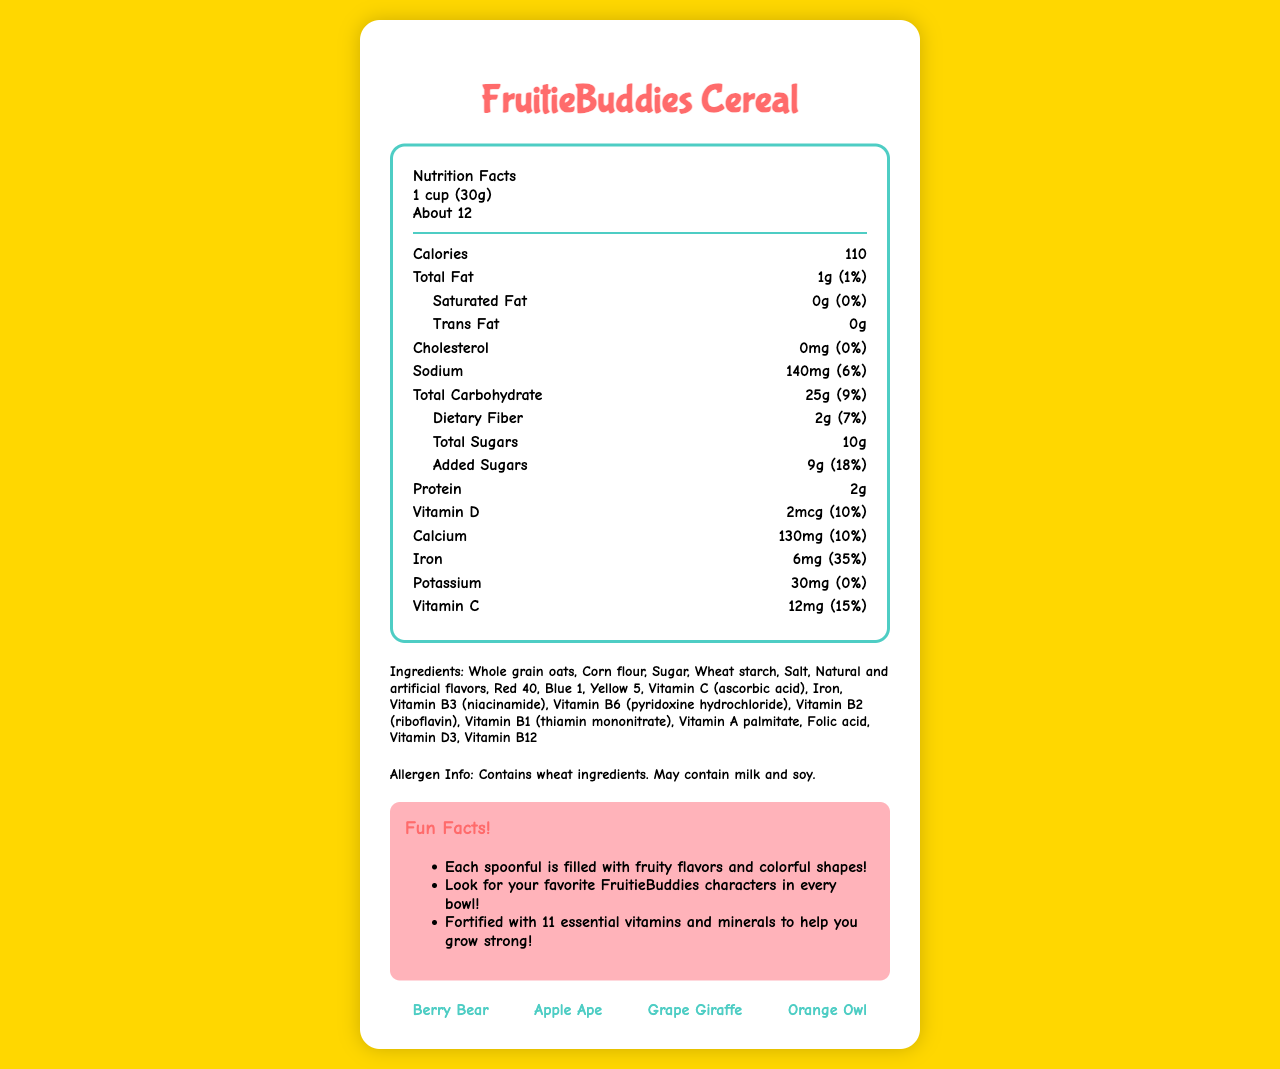How many calories are in a serving of FruitieBuddies Cereal? The document states that each serving of FruitieBuddies Cereal contains 110 calories.
Answer: 110 What is the serving size for FruitieBuddies Cereal? The serving size is explicitly mentioned as 1 cup (30g) in the document.
Answer: 1 cup (30g) How much iron does one serving of FruitieBuddies Cereal provide? The document specifies that each serving includes 6mg of iron, which is 35% of the daily value.
Answer: 6mg What is the total amount of fat in one serving? The label shows that there is 1g of total fat per serving, which is 1% of the daily value.
Answer: 1g Name one of the mascots for FruitieBuddies Cereal. The document lists Berry Bear, Apple Ape, Grape Giraffe, and Orange Owl as mascots.
Answer: Berry Bear How many servings are there in a container? A. 10 B. 12 C. About 12 The document states that there are "About 12" servings per container.
Answer: C How much Vitamin D is in a serving of FruitieBuddies Cereal? A. 2mcg B. 5mcg C. 10mcg The label indicates that each serving contains 2mcg of Vitamin D, which is 10% of the daily value.
Answer: A Does FruitieBuddies Cereal have any added sugars? The document lists 9g of added sugars, which is 18% of the daily value.
Answer: Yes Does FruitieBuddies Cereal contain milk? The allergen info states that the cereal may contain milk and soy.
Answer: It may contain milk. Describe the main idea of the document. The document provides comprehensive information about FruitieBuddies Cereal, including serving size, nutritional values, ingredients, potential allergens, fun facts, and the cereal's mascots.
Answer: The document details the nutritional information, ingredients, allergen info, fun facts, and mascots of FruitieBuddies Cereal. What are the flavors of FruitieBuddies Cereal? The document does not specify the exact flavors of the cereal; it only mentions that it is fruit-flavored.
Answer: Cannot be determined 